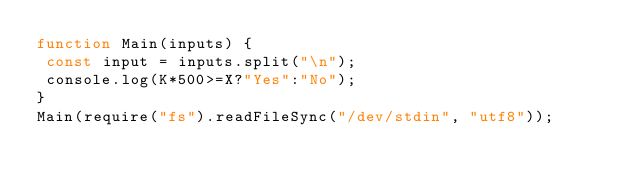<code> <loc_0><loc_0><loc_500><loc_500><_JavaScript_>function Main(inputs) {
 const input = inputs.split("\n");
 console.log(K*500>=X?"Yes":"No");
}
Main(require("fs").readFileSync("/dev/stdin", "utf8"));</code> 